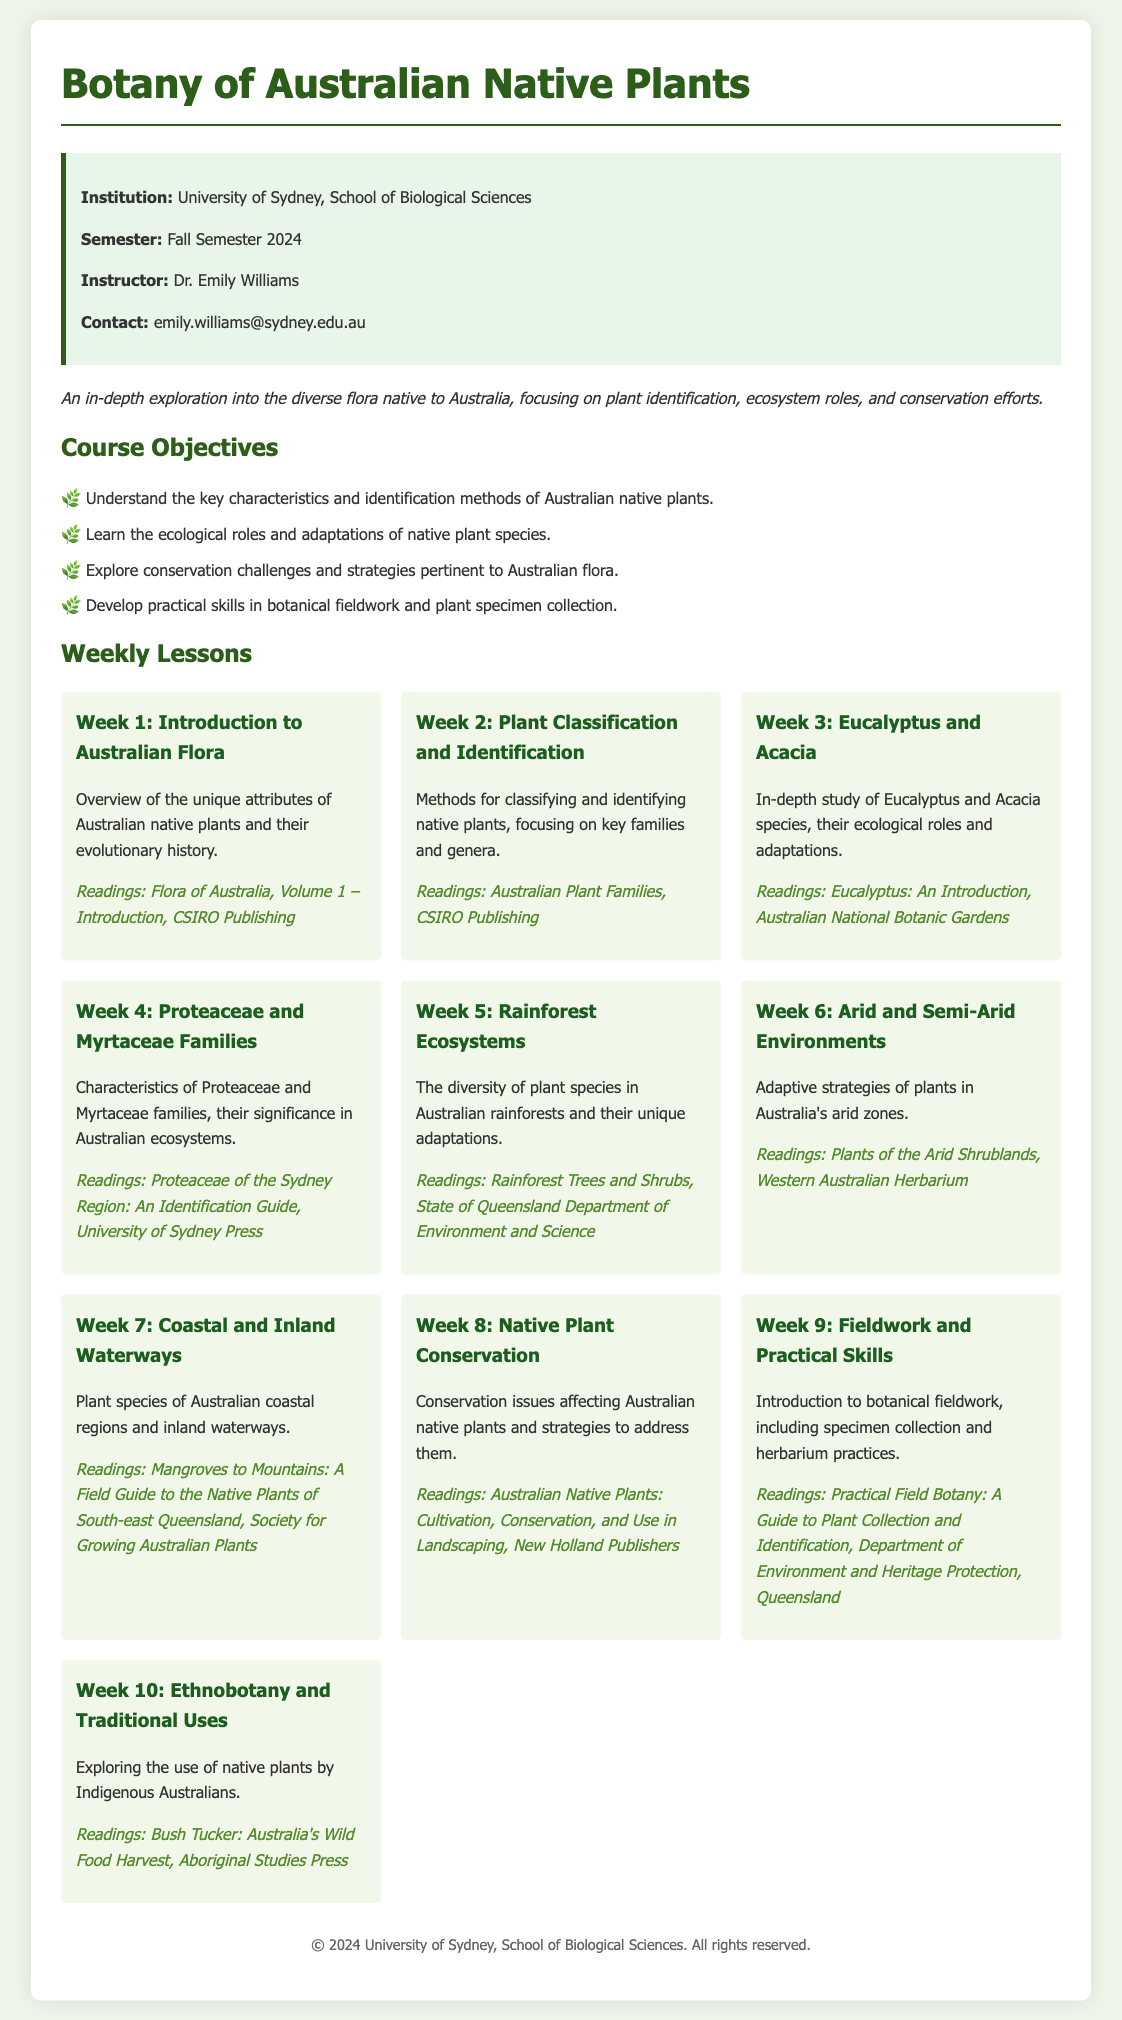What is the title of the course? The title of the course is mentioned at the top of the document.
Answer: Botany of Australian Native Plants Who is the instructor for the course? The instructor's name is provided in the course information section.
Answer: Dr. Emily Williams In which semester is the course offered? The semester of the course offering is specified in the course information section.
Answer: Fall Semester 2024 List one objective of the course. The objectives are listed under the Course Objectives section; any one can be provided as an answer.
Answer: Understand the key characteristics and identification methods of Australian native plants What is the reading for Week 3? The readings for each week are provided in the weekly lessons; this is specifically asked for week 3.
Answer: Eucalyptus: An Introduction, Australian National Botanic Gardens Which families are studied in Week 4? The families being studied are explicitly stated in the lesson title for that week.
Answer: Proteaceae and Myrtaceae What is the focus of Week 6? The lesson for that week summarizes the adaptive strategies discussed, which indicates the focus.
Answer: Adaptive strategies of plants in Australia's arid zones How many weeks are covered in the syllabus? The number of lessons indicates the total weeks covered in the course syllabus.
Answer: 10 What is the email contact for the instructor? The contact details for the instructor are directly provided in the course information section.
Answer: emily.williams@sydney.edu.au 